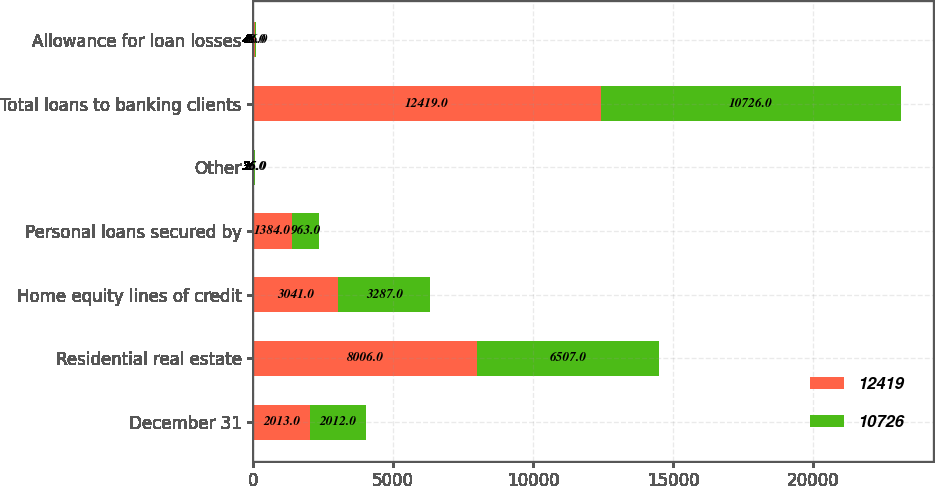<chart> <loc_0><loc_0><loc_500><loc_500><stacked_bar_chart><ecel><fcel>December 31<fcel>Residential real estate<fcel>Home equity lines of credit<fcel>Personal loans secured by<fcel>Other<fcel>Total loans to banking clients<fcel>Allowance for loan losses<nl><fcel>12419<fcel>2013<fcel>8006<fcel>3041<fcel>1384<fcel>36<fcel>12419<fcel>48<nl><fcel>10726<fcel>2012<fcel>6507<fcel>3287<fcel>963<fcel>25<fcel>10726<fcel>56<nl></chart> 